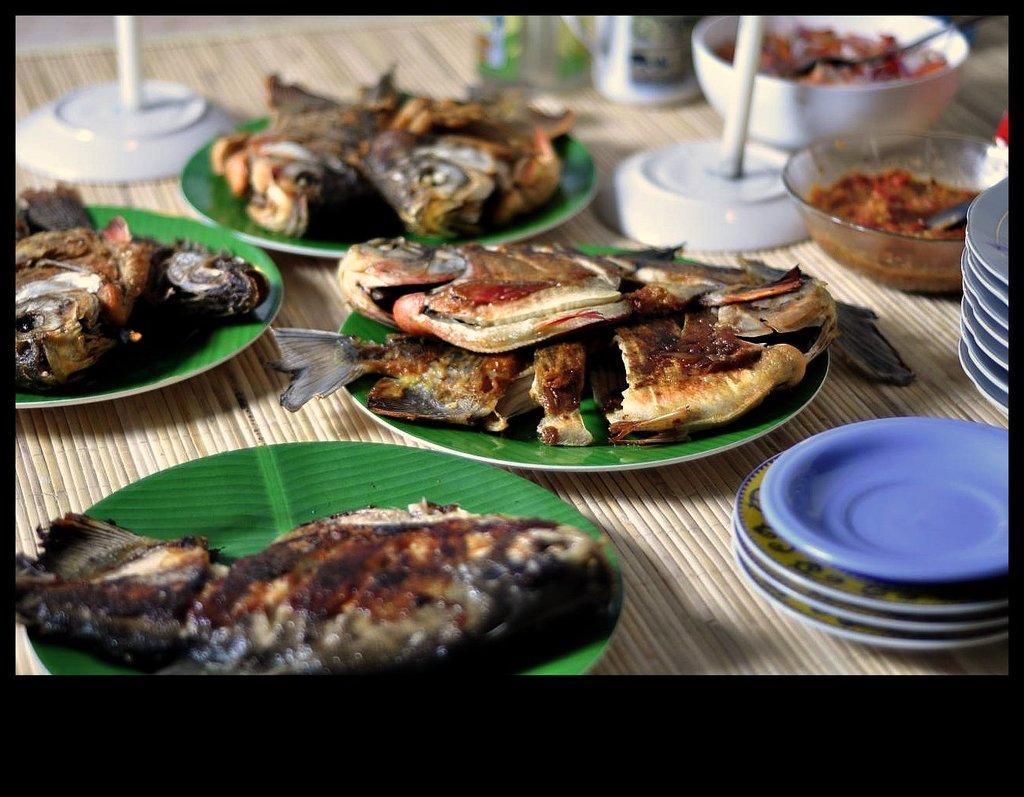Can you describe this image briefly? In this image there are plates and bowls on the table. There is food on the plates and in the bowls. There are spoons in the bowls. There is cooked fish on the plates. 